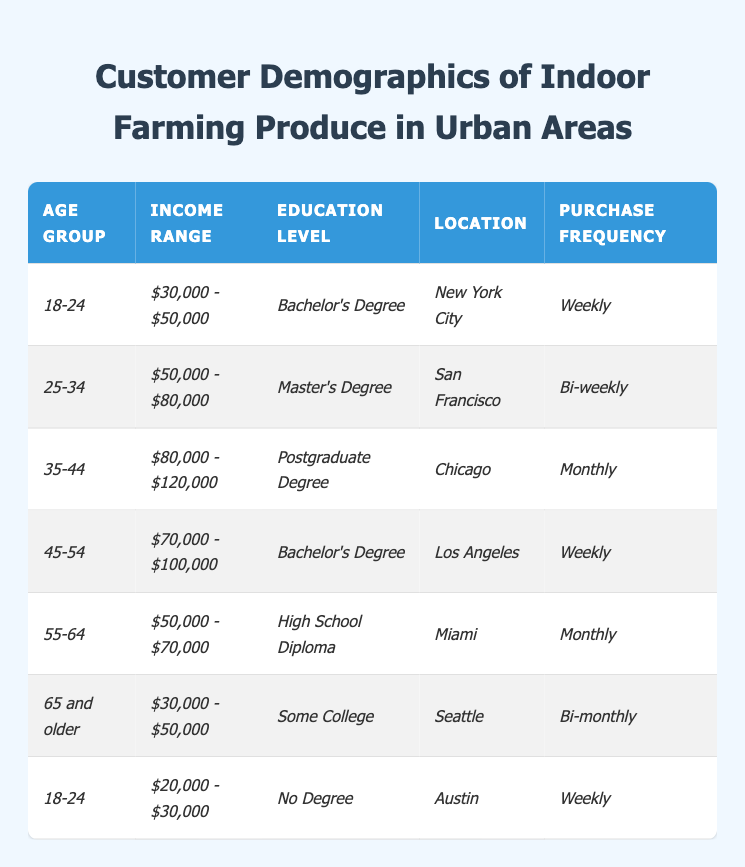What is the purchase frequency for customers aged 25-34? The table shows that individuals in the age group of 25-34 have a purchase frequency listed as "Bi-weekly."
Answer: Bi-weekly Which city has the highest average income range among the listed demographics? Comparing the income ranges, Chicago has an income range of "$80,000 - $120,000," which is the highest when compared to the others.
Answer: Chicago What percentage of customers aged 18-24 have a Bachelor's Degree? There are two entries for the age group 18-24, one with a Bachelor's Degree and another with No Degree, representing 50% of customers in that age group having a Bachelor's Degree.
Answer: 50% Is there a demographic group that purchases indoor farming produce monthly? Yes, there are two demographic groups that purchase monthly: one aged 35-44 and another aged 55-64.
Answer: Yes What is the average income range of customers who live in Miami and have a monthly purchase frequency? The customer in Miami has an income range of "$50,000 - $70,000." Since there is only one entry, the average is the same as the income range, which is $50,000 - $70,000.
Answer: $50,000 - $70,000 What is the most common purchase frequency among customers aged 45-54 and 65 and older? The 45-54 age group has a purchase frequency of "Weekly," while the 65 and older group has a frequency of "Bi-monthly." The most common among the two frequencies is "Weekly."
Answer: Weekly How many customers across all age groups purchase produce weekly? Two customers aged 18-24 and 45-54 purchase weekly, giving a total of 2 customers who have this frequency across the age groups.
Answer: 2 What is the level of education for customers located in Seattle? According to the table, customers in Seattle have "Some College" as their education level.
Answer: Some College Are there any customers with a purchase frequency of "Bi-monthly" who have an income range below $50,000? Analyzing the data, the only customer with "Bi-monthly" frequency is aged 65 and older, with an income range of "$30,000 - $50,000," which is not below $50,000. So, the statement is false.
Answer: No 